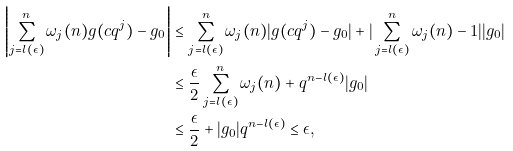<formula> <loc_0><loc_0><loc_500><loc_500>\left | \sum _ { j = l ( \epsilon ) } ^ { n } \omega _ { j } ( n ) g ( c q ^ { j } ) - g _ { 0 } \right | & \leq \sum _ { j = l ( \epsilon ) } ^ { n } \omega _ { j } ( n ) | g ( c q ^ { j } ) - g _ { 0 } | + | \sum _ { j = l ( \epsilon ) } ^ { n } \omega _ { j } ( n ) - 1 | | g _ { 0 } | \\ & \leq \frac { \epsilon } { 2 } \sum _ { j = l ( \epsilon ) } ^ { n } \omega _ { j } ( n ) + q ^ { n - l ( \epsilon ) } | g _ { 0 } | \\ & \leq \frac { \epsilon } { 2 } + | g _ { 0 } | q ^ { n - l ( \epsilon ) } \leq \epsilon ,</formula> 